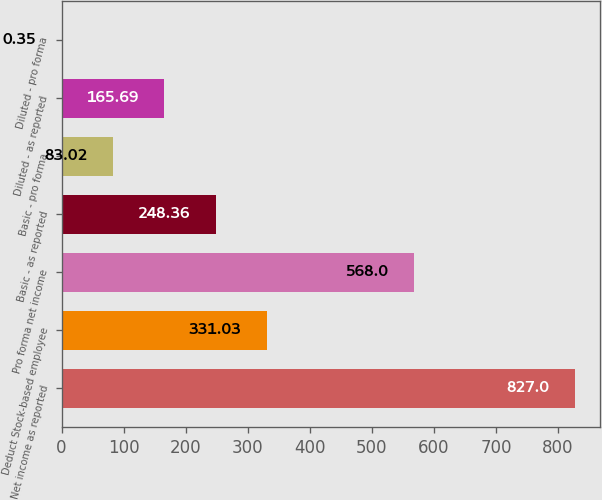Convert chart. <chart><loc_0><loc_0><loc_500><loc_500><bar_chart><fcel>Net income as reported<fcel>Deduct Stock-based employee<fcel>Pro forma net income<fcel>Basic - as reported<fcel>Basic - pro forma<fcel>Diluted - as reported<fcel>Diluted - pro forma<nl><fcel>827<fcel>331.03<fcel>568<fcel>248.36<fcel>83.02<fcel>165.69<fcel>0.35<nl></chart> 